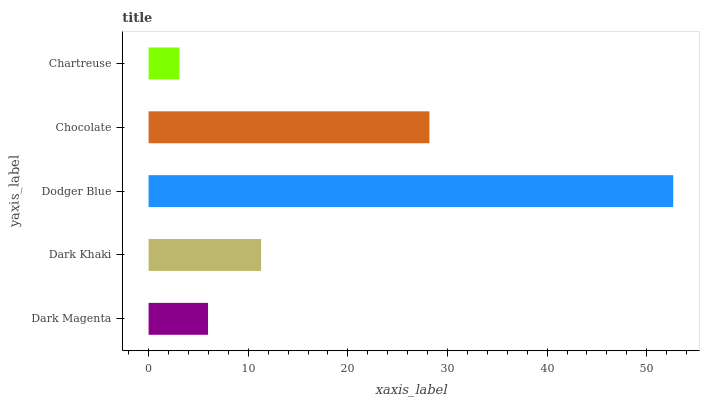Is Chartreuse the minimum?
Answer yes or no. Yes. Is Dodger Blue the maximum?
Answer yes or no. Yes. Is Dark Khaki the minimum?
Answer yes or no. No. Is Dark Khaki the maximum?
Answer yes or no. No. Is Dark Khaki greater than Dark Magenta?
Answer yes or no. Yes. Is Dark Magenta less than Dark Khaki?
Answer yes or no. Yes. Is Dark Magenta greater than Dark Khaki?
Answer yes or no. No. Is Dark Khaki less than Dark Magenta?
Answer yes or no. No. Is Dark Khaki the high median?
Answer yes or no. Yes. Is Dark Khaki the low median?
Answer yes or no. Yes. Is Chocolate the high median?
Answer yes or no. No. Is Dodger Blue the low median?
Answer yes or no. No. 